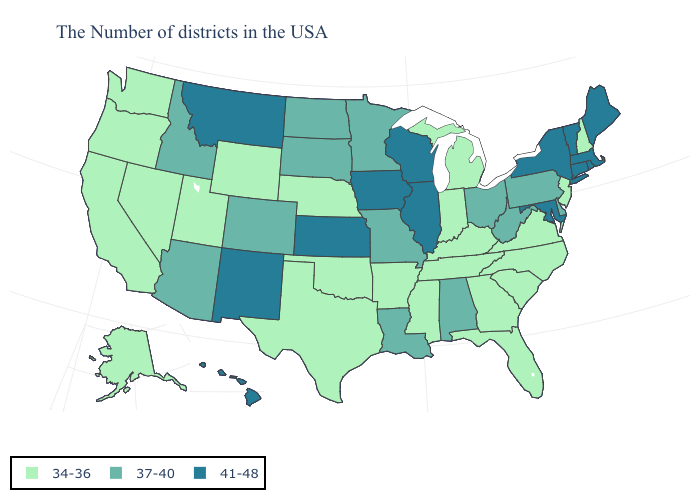Which states have the highest value in the USA?
Write a very short answer. Maine, Massachusetts, Rhode Island, Vermont, Connecticut, New York, Maryland, Wisconsin, Illinois, Iowa, Kansas, New Mexico, Montana, Hawaii. What is the value of New Hampshire?
Be succinct. 34-36. Name the states that have a value in the range 41-48?
Write a very short answer. Maine, Massachusetts, Rhode Island, Vermont, Connecticut, New York, Maryland, Wisconsin, Illinois, Iowa, Kansas, New Mexico, Montana, Hawaii. Which states hav the highest value in the West?
Quick response, please. New Mexico, Montana, Hawaii. Does New Mexico have the lowest value in the West?
Be succinct. No. What is the highest value in the USA?
Keep it brief. 41-48. Does Delaware have the lowest value in the South?
Concise answer only. No. Among the states that border Kentucky , which have the highest value?
Short answer required. Illinois. Name the states that have a value in the range 37-40?
Answer briefly. Delaware, Pennsylvania, West Virginia, Ohio, Alabama, Louisiana, Missouri, Minnesota, South Dakota, North Dakota, Colorado, Arizona, Idaho. Among the states that border Massachusetts , which have the highest value?
Answer briefly. Rhode Island, Vermont, Connecticut, New York. Which states hav the highest value in the South?
Be succinct. Maryland. Does Alabama have the lowest value in the South?
Answer briefly. No. What is the value of Massachusetts?
Quick response, please. 41-48. What is the highest value in the South ?
Quick response, please. 41-48. Does the map have missing data?
Give a very brief answer. No. 